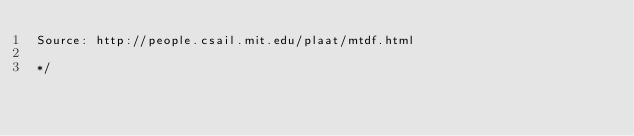<code> <loc_0><loc_0><loc_500><loc_500><_Rust_>Source: http://people.csail.mit.edu/plaat/mtdf.html

*/
</code> 